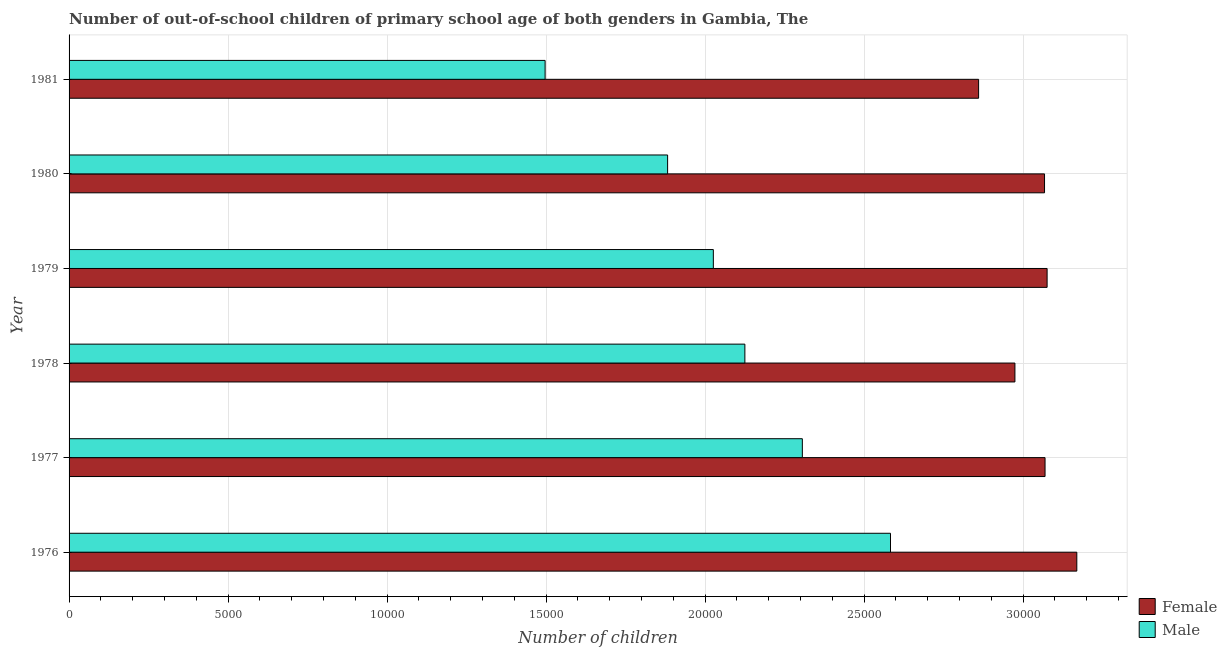How many different coloured bars are there?
Keep it short and to the point. 2. How many groups of bars are there?
Ensure brevity in your answer.  6. Are the number of bars per tick equal to the number of legend labels?
Provide a short and direct response. Yes. Are the number of bars on each tick of the Y-axis equal?
Make the answer very short. Yes. How many bars are there on the 5th tick from the top?
Your response must be concise. 2. How many bars are there on the 6th tick from the bottom?
Your answer should be very brief. 2. What is the label of the 6th group of bars from the top?
Give a very brief answer. 1976. In how many cases, is the number of bars for a given year not equal to the number of legend labels?
Ensure brevity in your answer.  0. What is the number of male out-of-school students in 1978?
Give a very brief answer. 2.13e+04. Across all years, what is the maximum number of female out-of-school students?
Give a very brief answer. 3.17e+04. Across all years, what is the minimum number of male out-of-school students?
Give a very brief answer. 1.50e+04. In which year was the number of female out-of-school students maximum?
Your response must be concise. 1976. In which year was the number of female out-of-school students minimum?
Provide a succinct answer. 1981. What is the total number of female out-of-school students in the graph?
Make the answer very short. 1.82e+05. What is the difference between the number of male out-of-school students in 1977 and that in 1978?
Your response must be concise. 1807. What is the difference between the number of female out-of-school students in 1979 and the number of male out-of-school students in 1981?
Ensure brevity in your answer.  1.58e+04. What is the average number of male out-of-school students per year?
Your answer should be compact. 2.07e+04. In the year 1979, what is the difference between the number of male out-of-school students and number of female out-of-school students?
Provide a short and direct response. -1.05e+04. What is the ratio of the number of male out-of-school students in 1976 to that in 1981?
Ensure brevity in your answer.  1.73. Is the difference between the number of female out-of-school students in 1976 and 1977 greater than the difference between the number of male out-of-school students in 1976 and 1977?
Your response must be concise. No. What is the difference between the highest and the second highest number of female out-of-school students?
Offer a terse response. 934. What is the difference between the highest and the lowest number of male out-of-school students?
Ensure brevity in your answer.  1.09e+04. What does the 1st bar from the bottom in 1979 represents?
Give a very brief answer. Female. How many bars are there?
Keep it short and to the point. 12. Are all the bars in the graph horizontal?
Make the answer very short. Yes. Are the values on the major ticks of X-axis written in scientific E-notation?
Provide a short and direct response. No. Does the graph contain any zero values?
Your response must be concise. No. Does the graph contain grids?
Your answer should be compact. Yes. Where does the legend appear in the graph?
Keep it short and to the point. Bottom right. What is the title of the graph?
Keep it short and to the point. Number of out-of-school children of primary school age of both genders in Gambia, The. What is the label or title of the X-axis?
Your response must be concise. Number of children. What is the label or title of the Y-axis?
Offer a very short reply. Year. What is the Number of children of Female in 1976?
Give a very brief answer. 3.17e+04. What is the Number of children of Male in 1976?
Make the answer very short. 2.58e+04. What is the Number of children of Female in 1977?
Offer a very short reply. 3.07e+04. What is the Number of children in Male in 1977?
Your answer should be very brief. 2.31e+04. What is the Number of children in Female in 1978?
Offer a terse response. 2.97e+04. What is the Number of children in Male in 1978?
Ensure brevity in your answer.  2.13e+04. What is the Number of children in Female in 1979?
Ensure brevity in your answer.  3.08e+04. What is the Number of children of Male in 1979?
Offer a terse response. 2.03e+04. What is the Number of children in Female in 1980?
Ensure brevity in your answer.  3.07e+04. What is the Number of children of Male in 1980?
Offer a very short reply. 1.88e+04. What is the Number of children in Female in 1981?
Your response must be concise. 2.86e+04. What is the Number of children in Male in 1981?
Your answer should be very brief. 1.50e+04. Across all years, what is the maximum Number of children in Female?
Keep it short and to the point. 3.17e+04. Across all years, what is the maximum Number of children of Male?
Make the answer very short. 2.58e+04. Across all years, what is the minimum Number of children of Female?
Offer a terse response. 2.86e+04. Across all years, what is the minimum Number of children of Male?
Keep it short and to the point. 1.50e+04. What is the total Number of children in Female in the graph?
Offer a terse response. 1.82e+05. What is the total Number of children in Male in the graph?
Ensure brevity in your answer.  1.24e+05. What is the difference between the Number of children of Female in 1976 and that in 1977?
Offer a terse response. 999. What is the difference between the Number of children in Male in 1976 and that in 1977?
Provide a short and direct response. 2772. What is the difference between the Number of children in Female in 1976 and that in 1978?
Provide a short and direct response. 1946. What is the difference between the Number of children of Male in 1976 and that in 1978?
Your answer should be compact. 4579. What is the difference between the Number of children of Female in 1976 and that in 1979?
Offer a very short reply. 934. What is the difference between the Number of children in Male in 1976 and that in 1979?
Keep it short and to the point. 5571. What is the difference between the Number of children in Female in 1976 and that in 1980?
Your answer should be compact. 1015. What is the difference between the Number of children of Male in 1976 and that in 1980?
Your answer should be compact. 7009. What is the difference between the Number of children in Female in 1976 and that in 1981?
Provide a succinct answer. 3088. What is the difference between the Number of children in Male in 1976 and that in 1981?
Ensure brevity in your answer.  1.09e+04. What is the difference between the Number of children in Female in 1977 and that in 1978?
Your response must be concise. 947. What is the difference between the Number of children of Male in 1977 and that in 1978?
Ensure brevity in your answer.  1807. What is the difference between the Number of children of Female in 1977 and that in 1979?
Offer a very short reply. -65. What is the difference between the Number of children in Male in 1977 and that in 1979?
Offer a very short reply. 2799. What is the difference between the Number of children in Male in 1977 and that in 1980?
Offer a terse response. 4237. What is the difference between the Number of children of Female in 1977 and that in 1981?
Provide a succinct answer. 2089. What is the difference between the Number of children in Male in 1977 and that in 1981?
Make the answer very short. 8089. What is the difference between the Number of children in Female in 1978 and that in 1979?
Provide a short and direct response. -1012. What is the difference between the Number of children of Male in 1978 and that in 1979?
Offer a very short reply. 992. What is the difference between the Number of children in Female in 1978 and that in 1980?
Offer a terse response. -931. What is the difference between the Number of children of Male in 1978 and that in 1980?
Your answer should be very brief. 2430. What is the difference between the Number of children in Female in 1978 and that in 1981?
Keep it short and to the point. 1142. What is the difference between the Number of children of Male in 1978 and that in 1981?
Make the answer very short. 6282. What is the difference between the Number of children of Female in 1979 and that in 1980?
Provide a short and direct response. 81. What is the difference between the Number of children of Male in 1979 and that in 1980?
Keep it short and to the point. 1438. What is the difference between the Number of children of Female in 1979 and that in 1981?
Offer a terse response. 2154. What is the difference between the Number of children in Male in 1979 and that in 1981?
Provide a succinct answer. 5290. What is the difference between the Number of children of Female in 1980 and that in 1981?
Ensure brevity in your answer.  2073. What is the difference between the Number of children in Male in 1980 and that in 1981?
Your response must be concise. 3852. What is the difference between the Number of children of Female in 1976 and the Number of children of Male in 1977?
Give a very brief answer. 8631. What is the difference between the Number of children of Female in 1976 and the Number of children of Male in 1978?
Provide a succinct answer. 1.04e+04. What is the difference between the Number of children in Female in 1976 and the Number of children in Male in 1979?
Make the answer very short. 1.14e+04. What is the difference between the Number of children in Female in 1976 and the Number of children in Male in 1980?
Make the answer very short. 1.29e+04. What is the difference between the Number of children in Female in 1976 and the Number of children in Male in 1981?
Your response must be concise. 1.67e+04. What is the difference between the Number of children in Female in 1977 and the Number of children in Male in 1978?
Your answer should be very brief. 9439. What is the difference between the Number of children in Female in 1977 and the Number of children in Male in 1979?
Your answer should be compact. 1.04e+04. What is the difference between the Number of children in Female in 1977 and the Number of children in Male in 1980?
Offer a very short reply. 1.19e+04. What is the difference between the Number of children of Female in 1977 and the Number of children of Male in 1981?
Provide a short and direct response. 1.57e+04. What is the difference between the Number of children in Female in 1978 and the Number of children in Male in 1979?
Ensure brevity in your answer.  9484. What is the difference between the Number of children of Female in 1978 and the Number of children of Male in 1980?
Offer a terse response. 1.09e+04. What is the difference between the Number of children in Female in 1978 and the Number of children in Male in 1981?
Your answer should be very brief. 1.48e+04. What is the difference between the Number of children in Female in 1979 and the Number of children in Male in 1980?
Provide a short and direct response. 1.19e+04. What is the difference between the Number of children in Female in 1979 and the Number of children in Male in 1981?
Offer a terse response. 1.58e+04. What is the difference between the Number of children in Female in 1980 and the Number of children in Male in 1981?
Provide a succinct answer. 1.57e+04. What is the average Number of children of Female per year?
Offer a very short reply. 3.04e+04. What is the average Number of children of Male per year?
Provide a succinct answer. 2.07e+04. In the year 1976, what is the difference between the Number of children of Female and Number of children of Male?
Ensure brevity in your answer.  5859. In the year 1977, what is the difference between the Number of children in Female and Number of children in Male?
Offer a terse response. 7632. In the year 1978, what is the difference between the Number of children of Female and Number of children of Male?
Provide a short and direct response. 8492. In the year 1979, what is the difference between the Number of children of Female and Number of children of Male?
Give a very brief answer. 1.05e+04. In the year 1980, what is the difference between the Number of children in Female and Number of children in Male?
Offer a terse response. 1.19e+04. In the year 1981, what is the difference between the Number of children of Female and Number of children of Male?
Give a very brief answer. 1.36e+04. What is the ratio of the Number of children of Female in 1976 to that in 1977?
Keep it short and to the point. 1.03. What is the ratio of the Number of children in Male in 1976 to that in 1977?
Provide a succinct answer. 1.12. What is the ratio of the Number of children of Female in 1976 to that in 1978?
Make the answer very short. 1.07. What is the ratio of the Number of children of Male in 1976 to that in 1978?
Keep it short and to the point. 1.22. What is the ratio of the Number of children of Female in 1976 to that in 1979?
Provide a succinct answer. 1.03. What is the ratio of the Number of children in Male in 1976 to that in 1979?
Offer a very short reply. 1.27. What is the ratio of the Number of children of Female in 1976 to that in 1980?
Keep it short and to the point. 1.03. What is the ratio of the Number of children of Male in 1976 to that in 1980?
Offer a terse response. 1.37. What is the ratio of the Number of children of Female in 1976 to that in 1981?
Give a very brief answer. 1.11. What is the ratio of the Number of children in Male in 1976 to that in 1981?
Your answer should be very brief. 1.73. What is the ratio of the Number of children of Female in 1977 to that in 1978?
Provide a short and direct response. 1.03. What is the ratio of the Number of children of Male in 1977 to that in 1978?
Keep it short and to the point. 1.08. What is the ratio of the Number of children in Male in 1977 to that in 1979?
Ensure brevity in your answer.  1.14. What is the ratio of the Number of children of Male in 1977 to that in 1980?
Keep it short and to the point. 1.23. What is the ratio of the Number of children of Female in 1977 to that in 1981?
Provide a short and direct response. 1.07. What is the ratio of the Number of children of Male in 1977 to that in 1981?
Your response must be concise. 1.54. What is the ratio of the Number of children of Female in 1978 to that in 1979?
Your answer should be very brief. 0.97. What is the ratio of the Number of children of Male in 1978 to that in 1979?
Provide a succinct answer. 1.05. What is the ratio of the Number of children in Female in 1978 to that in 1980?
Give a very brief answer. 0.97. What is the ratio of the Number of children of Male in 1978 to that in 1980?
Provide a succinct answer. 1.13. What is the ratio of the Number of children in Female in 1978 to that in 1981?
Your answer should be compact. 1.04. What is the ratio of the Number of children of Male in 1978 to that in 1981?
Your response must be concise. 1.42. What is the ratio of the Number of children in Female in 1979 to that in 1980?
Ensure brevity in your answer.  1. What is the ratio of the Number of children of Male in 1979 to that in 1980?
Offer a very short reply. 1.08. What is the ratio of the Number of children in Female in 1979 to that in 1981?
Provide a short and direct response. 1.08. What is the ratio of the Number of children in Male in 1979 to that in 1981?
Offer a very short reply. 1.35. What is the ratio of the Number of children of Female in 1980 to that in 1981?
Ensure brevity in your answer.  1.07. What is the ratio of the Number of children of Male in 1980 to that in 1981?
Your answer should be compact. 1.26. What is the difference between the highest and the second highest Number of children of Female?
Ensure brevity in your answer.  934. What is the difference between the highest and the second highest Number of children of Male?
Provide a succinct answer. 2772. What is the difference between the highest and the lowest Number of children of Female?
Make the answer very short. 3088. What is the difference between the highest and the lowest Number of children of Male?
Offer a very short reply. 1.09e+04. 